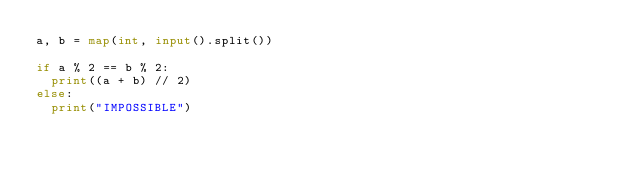<code> <loc_0><loc_0><loc_500><loc_500><_Python_>a, b = map(int, input().split())
 
if a % 2 == b % 2:
  print((a + b) // 2)
else:
  print("IMPOSSIBLE")</code> 